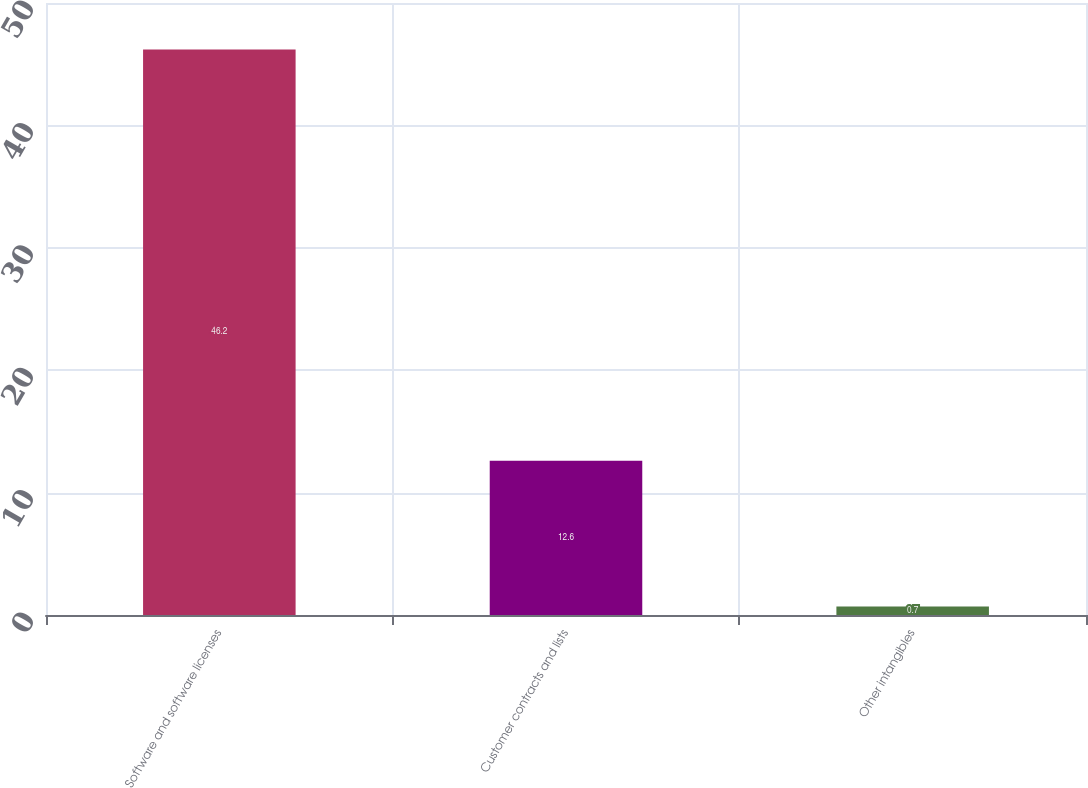Convert chart to OTSL. <chart><loc_0><loc_0><loc_500><loc_500><bar_chart><fcel>Software and software licenses<fcel>Customer contracts and lists<fcel>Other intangibles<nl><fcel>46.2<fcel>12.6<fcel>0.7<nl></chart> 